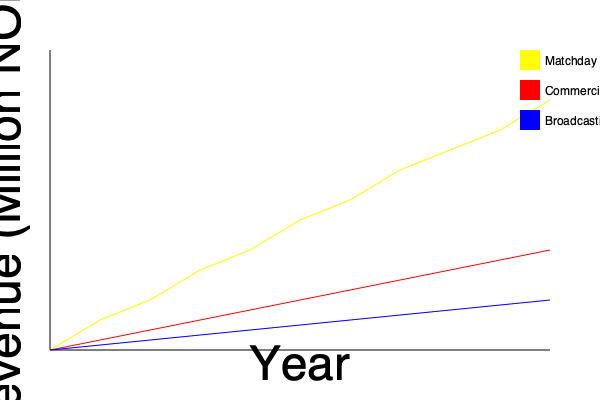Based on the stacked area chart showing Lillestrøm's financial performance over the past decade, which revenue stream has shown the most significant growth, and what could be a potential reason for this trend? To answer this question, we need to analyze the stacked area chart:

1. The chart shows three main revenue streams for Lillestrøm over the past decade: Matchday (yellow), Commercial (red), and Broadcasting (blue).

2. To determine which stream has shown the most significant growth, we need to compare the slopes of each line:
   - Matchday revenue (yellow) shows the steepest upward slope.
   - Commercial revenue (red) shows moderate growth.
   - Broadcasting revenue (blue) shows the least growth.

3. The Matchday revenue line has the steepest slope, indicating it has experienced the most significant growth over the decade.

4. Potential reasons for this growth in Matchday revenue could include:
   - Increased ticket prices
   - Higher attendance rates
   - Expansion of the stadium capacity
   - More home games or tournaments
   - Improved fan engagement and marketing strategies

5. The growth in Matchday revenue suggests that Lillestrøm has been successful in attracting more fans to their games and potentially improving the overall matchday experience.
Answer: Matchday revenue; possibly due to increased attendance and improved fan engagement. 